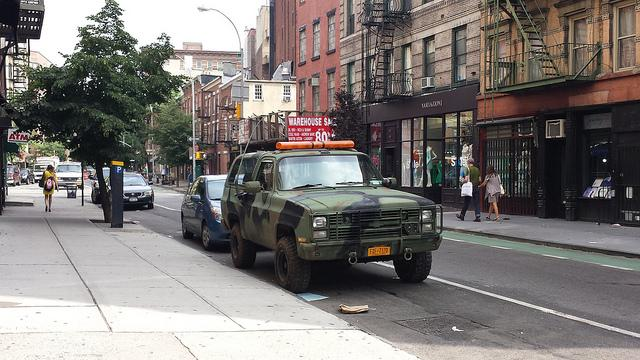Why does the truck have sign on top?

Choices:
A) original part
B) vandalism
C) keep score
D) advertising advertising 